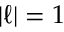<formula> <loc_0><loc_0><loc_500><loc_500>| \ell | = 1</formula> 